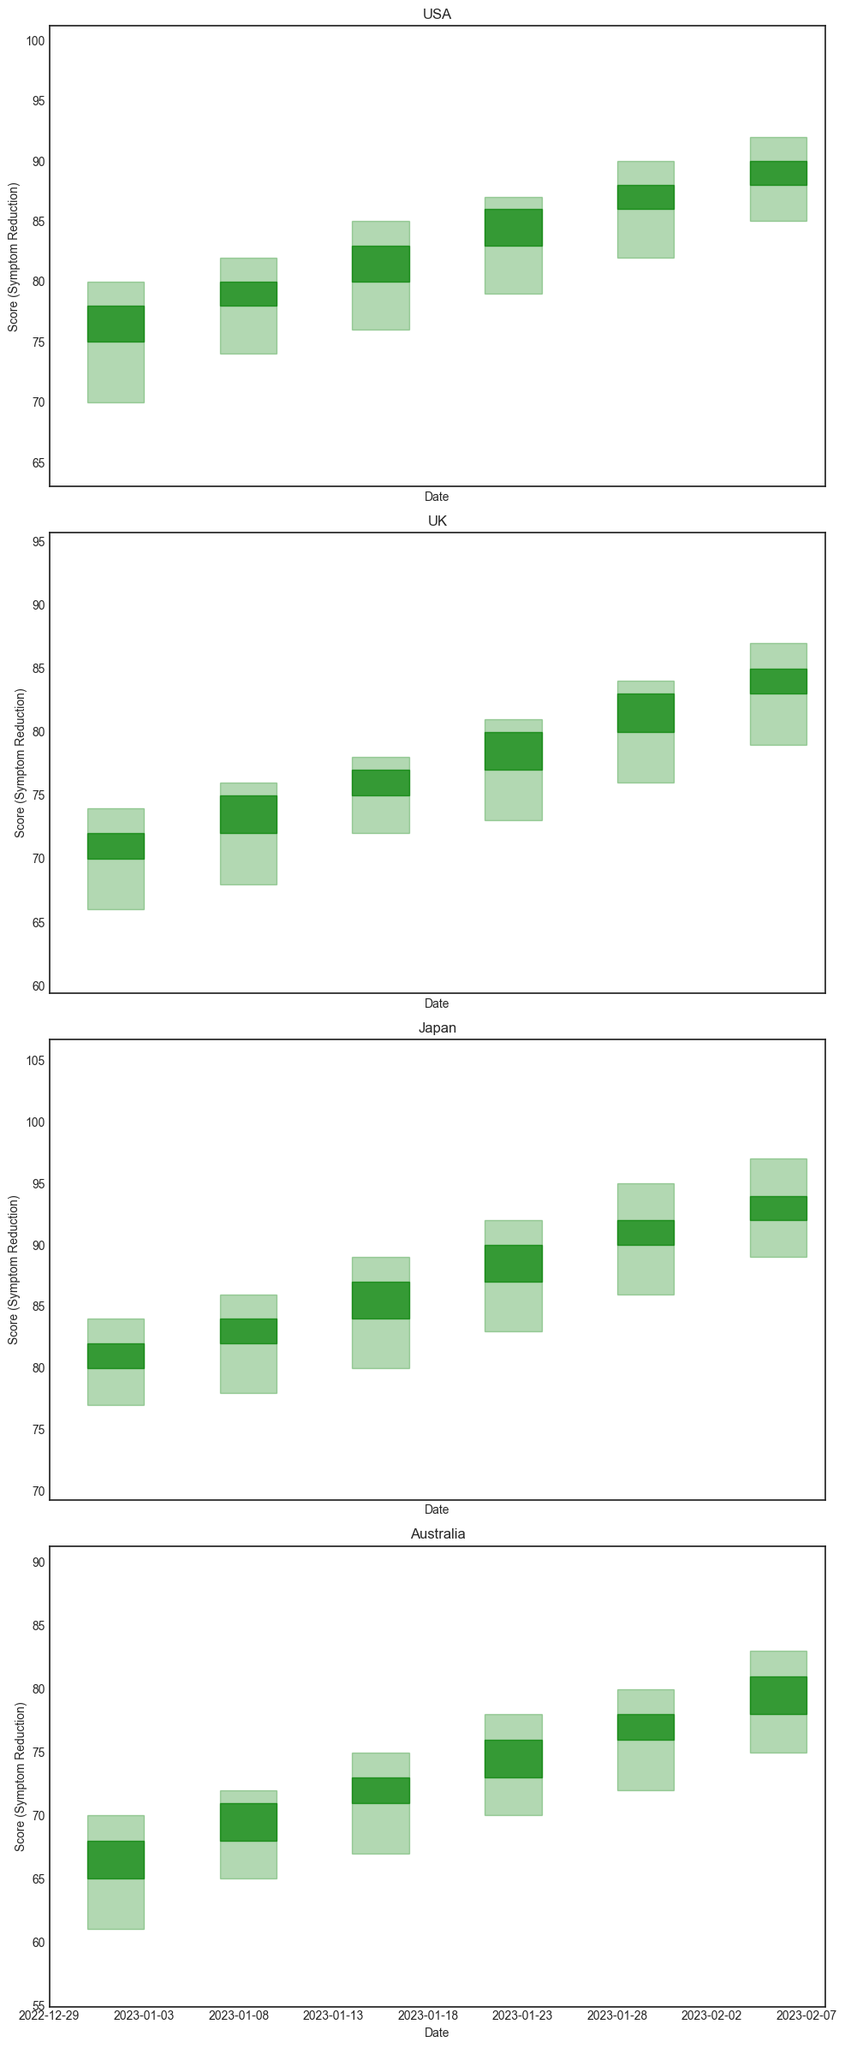What is the general trend for depression symptom reduction in participants from the USA? The candlestick chart for the USA shows a consistent increase in the 'Close' values each week from January 1 to February 5, indicating a steady reduction in depression symptoms among these participants.
Answer: Steady reduction How does the trend of symptom reduction in Japan compare to the UK? The candlestick chart shows that both countries exhibit a consistent upward trend in 'Close' values, indicating a reduction in symptoms. However, Japan's symptom reduction appears more pronounced, with higher 'Close' values by February 5 than the UK.
Answer: Japan has more pronounced reduction Between January 1 and January 29, which country shows the greatest increase in symptom reduction? By calculating the difference between the 'Close' values on January 1 and January 29 for each country, we get 88-78=10 (USA), 83-72=11 (UK), 92-82=10 (Japan), and 78-68=10 (Australia). The UK shows the greatest increase of 11.
Answer: UK Which country's symptom reduction data shows the highest volatility? Volatility can be seen as the range between 'High' and 'Low' values. Japan shows the highest values with a range of 11 (97-86), indicating high volatility in symptom reduction data.
Answer: Japan In terms of depression symptom reduction, which country had the lowest score on January 8? By comparing the 'Close' values on January 8 across all countries, Australia had the lowest score of 71.
Answer: Australia What is the average 'Close' value for the UK across all the weeks shown? The 'Close' values for the UK are 72, 75, 77, 80, 83, 85. Summing these values gives 472. Dividing by 6 weeks results in 78.67.
Answer: 78.67 Which country shows the least improvement in depression symptom reduction from January 15 to January 22? Calculating the difference in 'Close' values for January 15 and January 22 results in the USA (86-83=3), UK (80-77=3), Japan (90-87=3), Australia (76-73=3). All countries show the same improvement.
Answer: All countries show same improvement However, the overall visual trend:
What is the color of the candlesticks that indicate a week where the 'Close' value is higher than the 'Open' value? Candlesticks where the 'Close' value is higher than the 'Open' value are green, indicating a reduction in symptoms.
Answer: Green Between February 5 and January 1, which country shows the smallest percentage increase in symptom reduction? Calculate the percentage increase using the formula ((Close on Feb 5 - Close on Jan 1) / Close on Jan 1) * 100.
USA: ((90-78)/78)*100 = 15.38%
UK: ((85-72)/72)*100 = 18.06%
Japan: ((94-82)/82)*100 = 14.63%
Australia: ((81-68)/68)*100 = 19.12%
Japan shows the smallest percentage increase at 14.63%.
Answer: Japan 